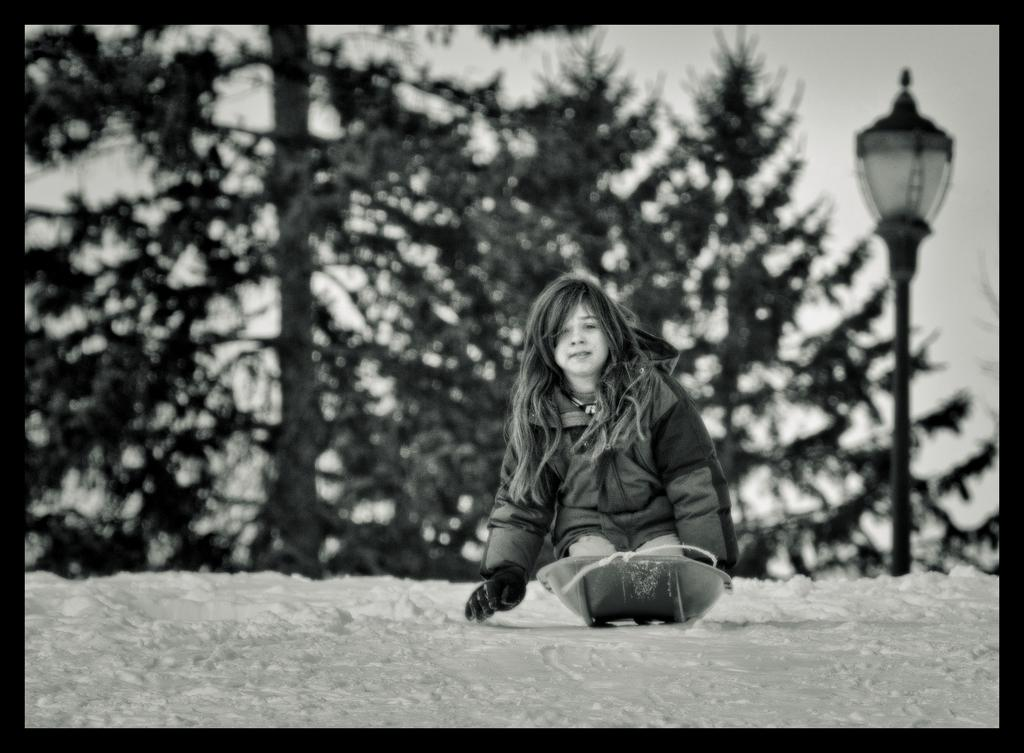What is the main subject in the center of the image? There is a child in the center of the image. What object can be seen in the image besides the child? There is a container in the image. What can be seen in the background of the image? There are trees and a light in the background of the image. What is the ground covered with at the bottom of the image? There is snow at the bottom of the image. What type of hose can be seen in the image? There is no hose present in the image. What crack is visible in the image? There is no crack visible in the image. 